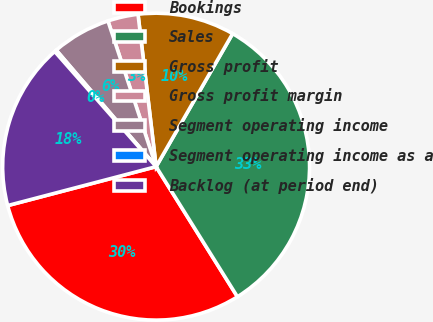Convert chart. <chart><loc_0><loc_0><loc_500><loc_500><pie_chart><fcel>Bookings<fcel>Sales<fcel>Gross profit<fcel>Gross profit margin<fcel>Segment operating income<fcel>Segment operating income as a<fcel>Backlog (at period end)<nl><fcel>29.81%<fcel>32.8%<fcel>10.19%<fcel>3.2%<fcel>6.2%<fcel>0.21%<fcel>17.59%<nl></chart> 